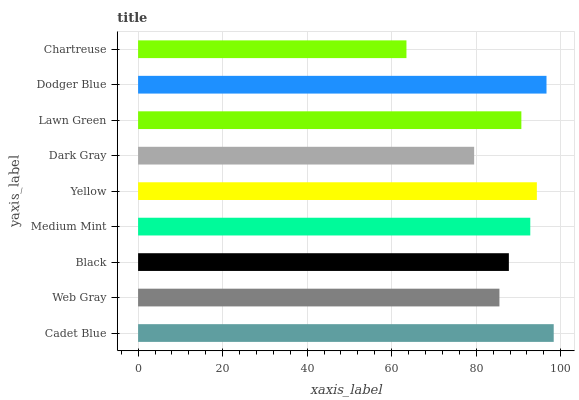Is Chartreuse the minimum?
Answer yes or no. Yes. Is Cadet Blue the maximum?
Answer yes or no. Yes. Is Web Gray the minimum?
Answer yes or no. No. Is Web Gray the maximum?
Answer yes or no. No. Is Cadet Blue greater than Web Gray?
Answer yes or no. Yes. Is Web Gray less than Cadet Blue?
Answer yes or no. Yes. Is Web Gray greater than Cadet Blue?
Answer yes or no. No. Is Cadet Blue less than Web Gray?
Answer yes or no. No. Is Lawn Green the high median?
Answer yes or no. Yes. Is Lawn Green the low median?
Answer yes or no. Yes. Is Dark Gray the high median?
Answer yes or no. No. Is Chartreuse the low median?
Answer yes or no. No. 